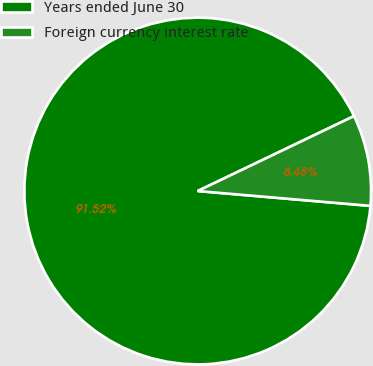Convert chart. <chart><loc_0><loc_0><loc_500><loc_500><pie_chart><fcel>Years ended June 30<fcel>Foreign currency interest rate<nl><fcel>91.52%<fcel>8.48%<nl></chart> 